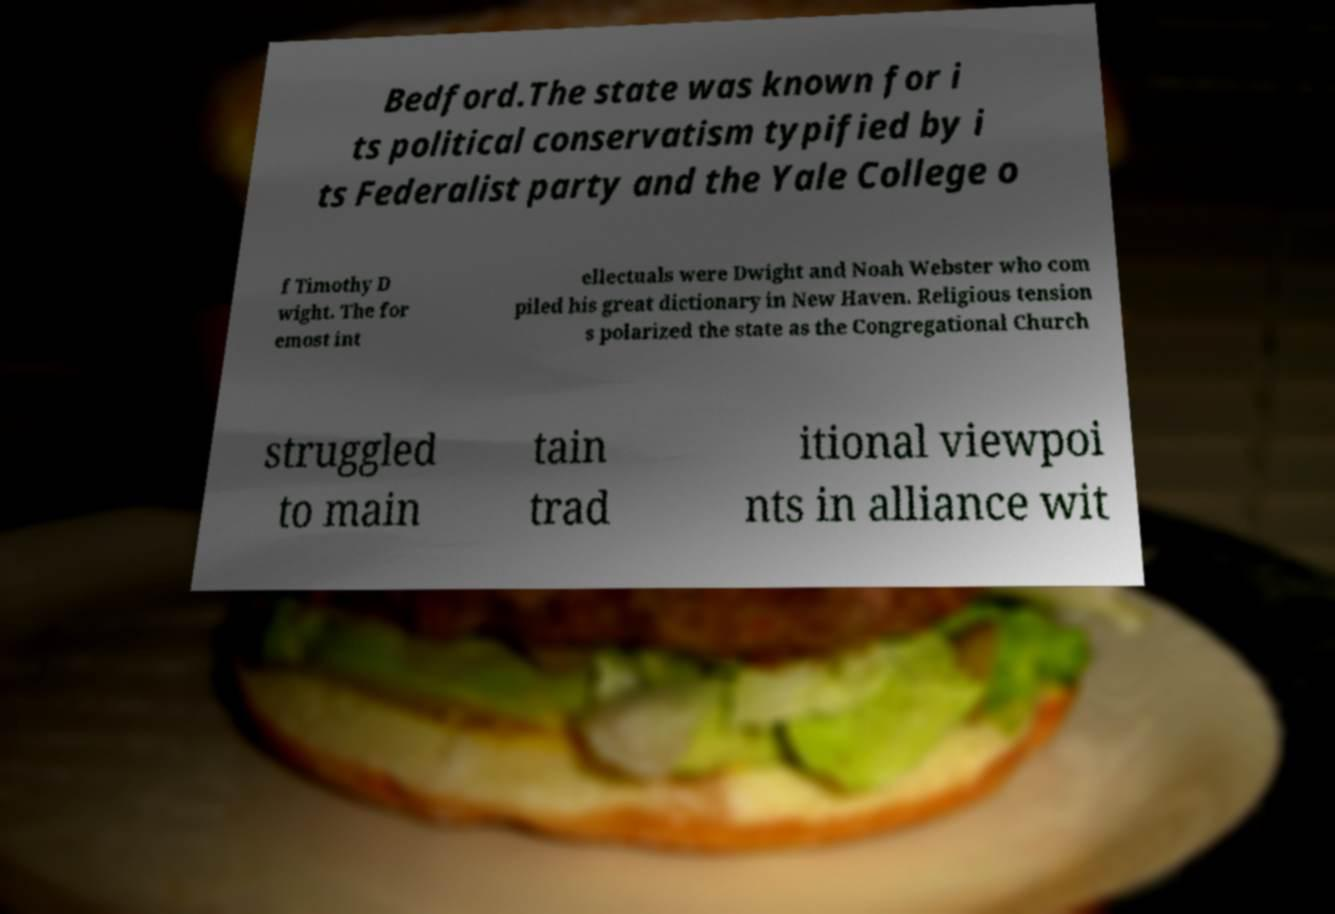Could you extract and type out the text from this image? Bedford.The state was known for i ts political conservatism typified by i ts Federalist party and the Yale College o f Timothy D wight. The for emost int ellectuals were Dwight and Noah Webster who com piled his great dictionary in New Haven. Religious tension s polarized the state as the Congregational Church struggled to main tain trad itional viewpoi nts in alliance wit 